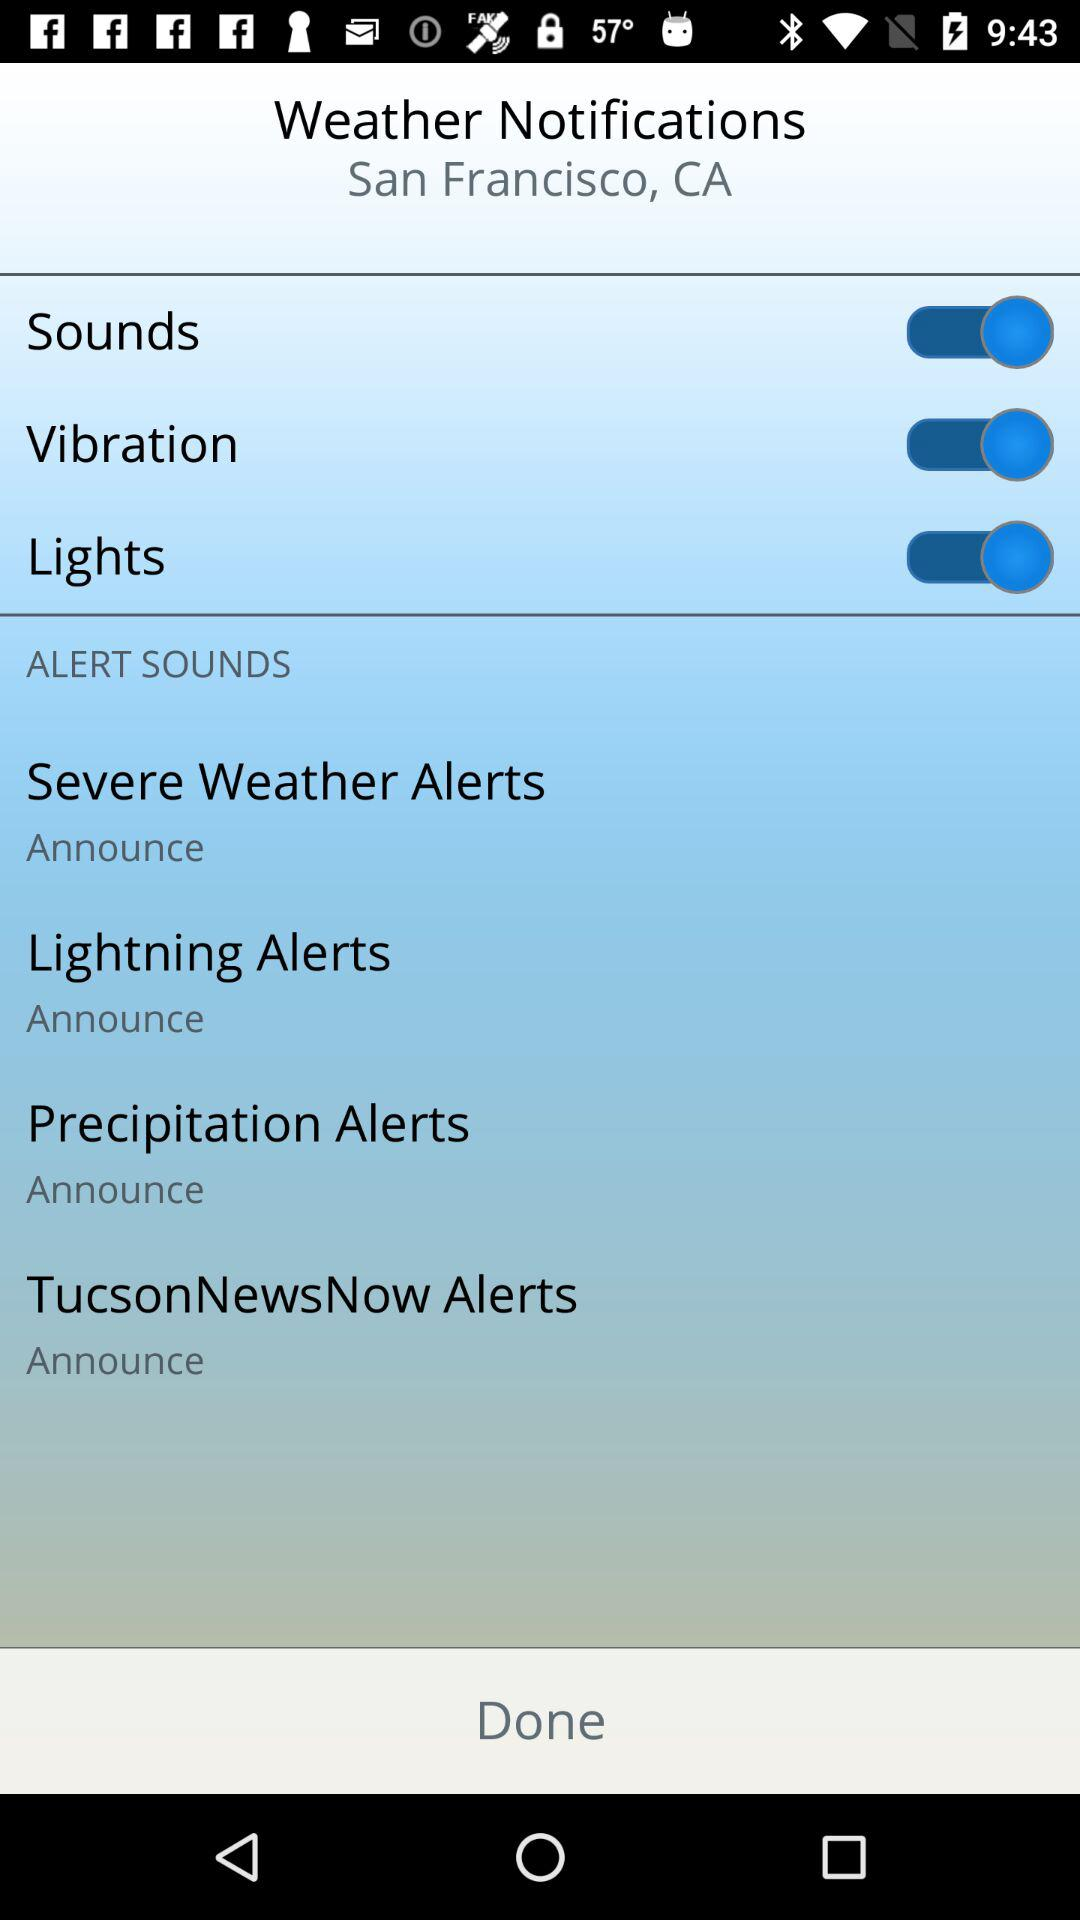What is the setting for the severe weather alerts notification? The setting for the severe weather alerts notification is "Announce". 